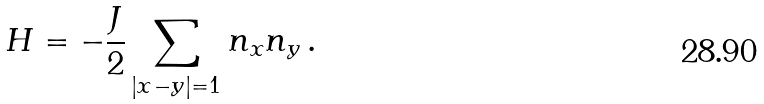<formula> <loc_0><loc_0><loc_500><loc_500>H = - \frac { J } { 2 } \sum _ { | x - y | = 1 } n _ { x } n _ { y } \, .</formula> 